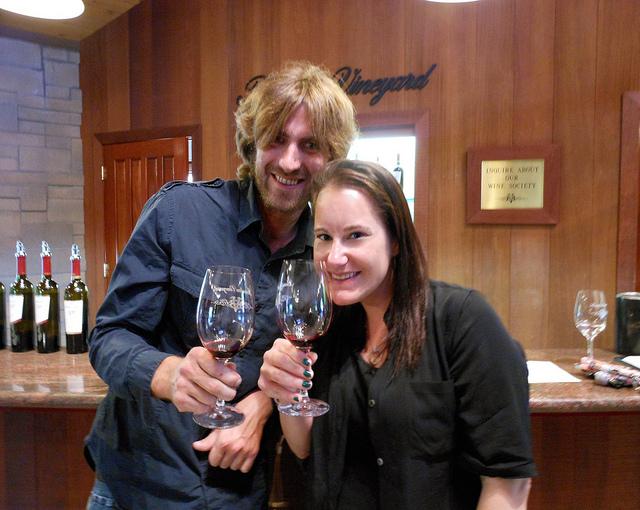Where are they?
Write a very short answer. Bar. What are they drinking?
Quick response, please. Wine. Is this couple at home?
Give a very brief answer. No. 